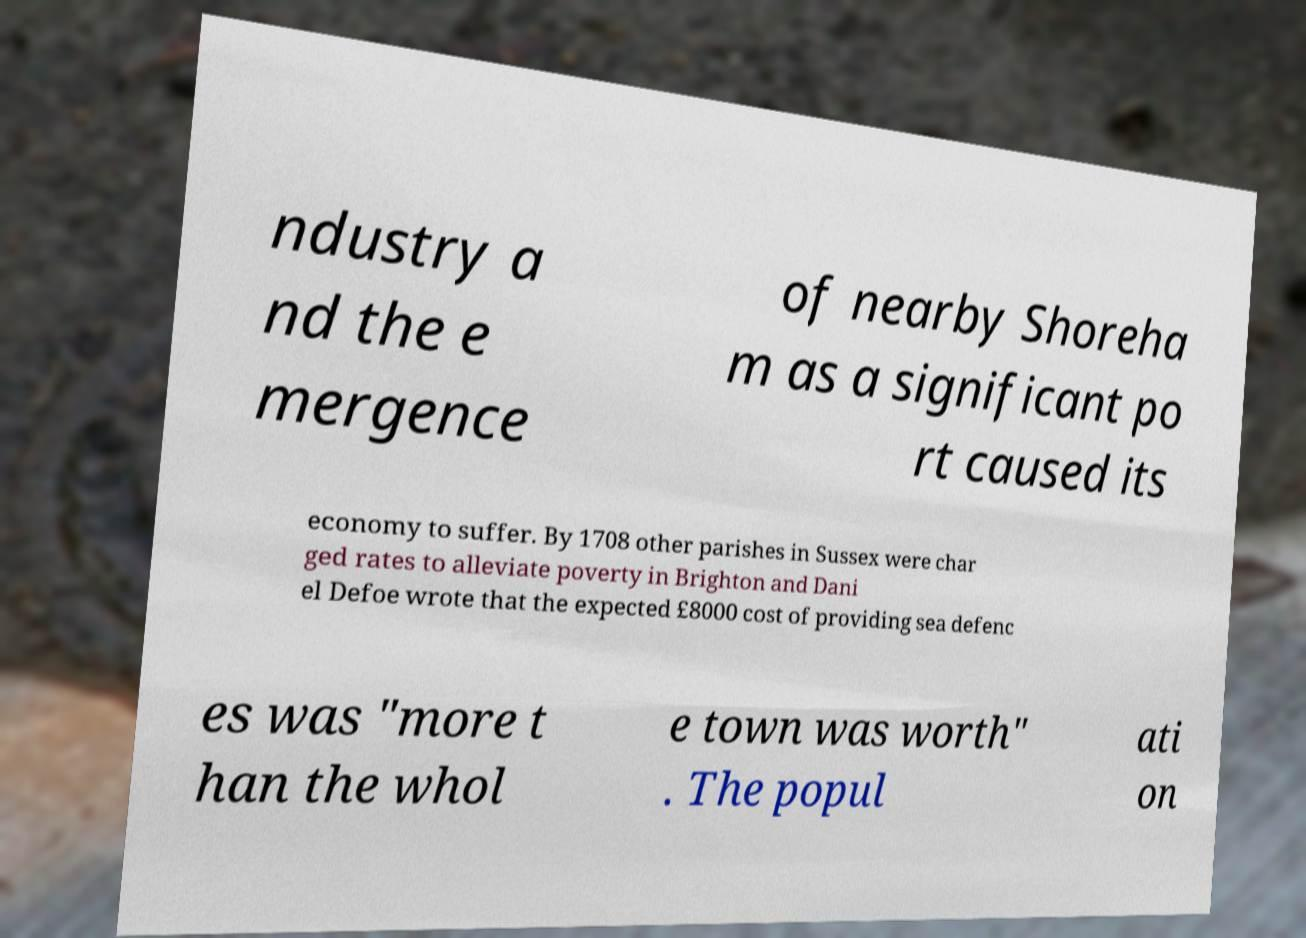I need the written content from this picture converted into text. Can you do that? ndustry a nd the e mergence of nearby Shoreha m as a significant po rt caused its economy to suffer. By 1708 other parishes in Sussex were char ged rates to alleviate poverty in Brighton and Dani el Defoe wrote that the expected £8000 cost of providing sea defenc es was "more t han the whol e town was worth" . The popul ati on 